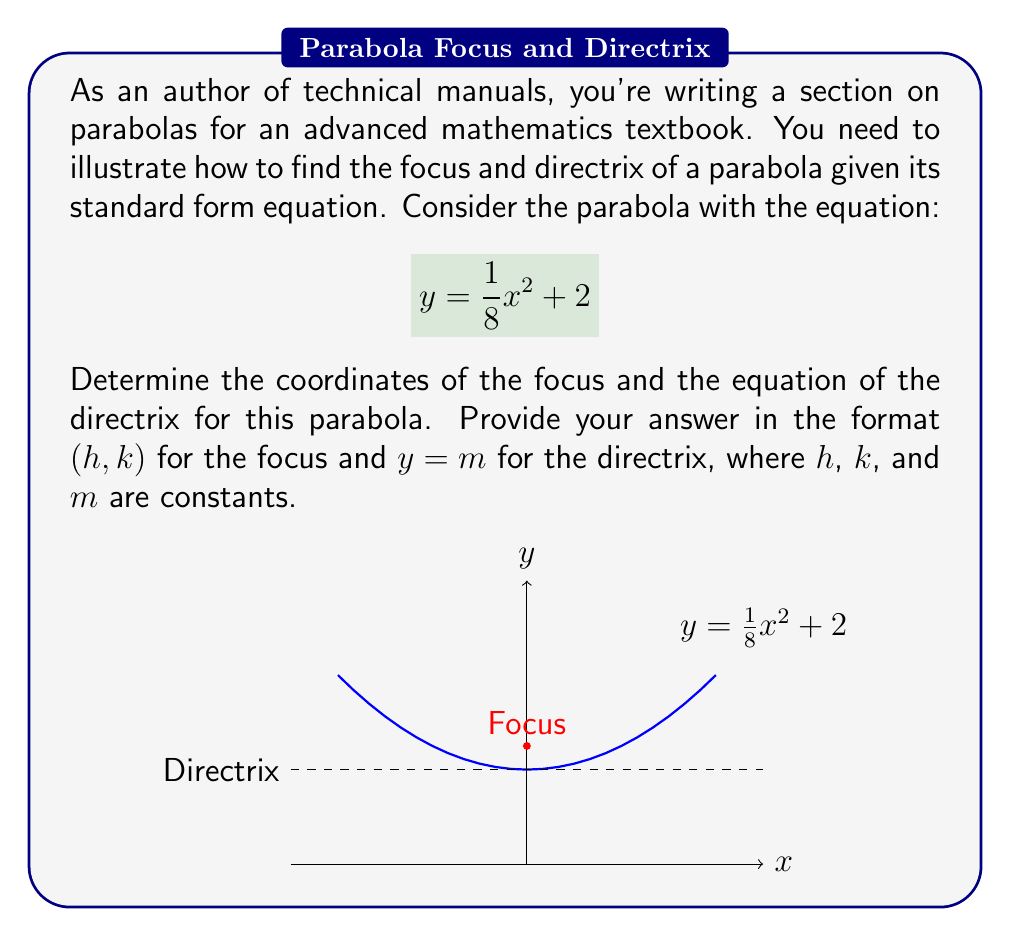Provide a solution to this math problem. Let's approach this step-by-step:

1) The standard form of a parabola with a vertical axis of symmetry is:
   $$y = a(x-h)^2 + k$$
   where (h,k) is the vertex and a determines the direction and width of the parabola.

2) Our equation is $$y = \frac{1}{8}x^2 + 2$$
   Comparing this to the standard form, we can see that:
   $a = \frac{1}{8}$, $h = 0$, and $k = 2$

3) The vertex of the parabola is (h,k) = (0,2)

4) For a parabola with a vertical axis of symmetry:
   - The distance from the vertex to the focus is $\frac{1}{4a}$
   - The distance from the vertex to the directrix is also $\frac{1}{4a}$

5) Calculate $\frac{1}{4a}$:
   $$\frac{1}{4a} = \frac{1}{4(\frac{1}{8})} = \frac{1}{1/2} = 2$$

6) Since $a$ is positive, the parabola opens upward. Therefore:
   - The focus is 2 units above the vertex
   - The directrix is 2 units below the vertex

7) Focus coordinates:
   x-coordinate = h = 0
   y-coordinate = k + $\frac{1}{4a}$ = 2 + 2 = 4
   So, the focus is at (0, 4)

8) Directrix equation:
   y = k - $\frac{1}{4a}$ = 2 - 2 = 0

Therefore, the focus is at (0, 4) and the directrix has the equation y = 0.
Answer: Focus: (0, 4); Directrix: y = 0 